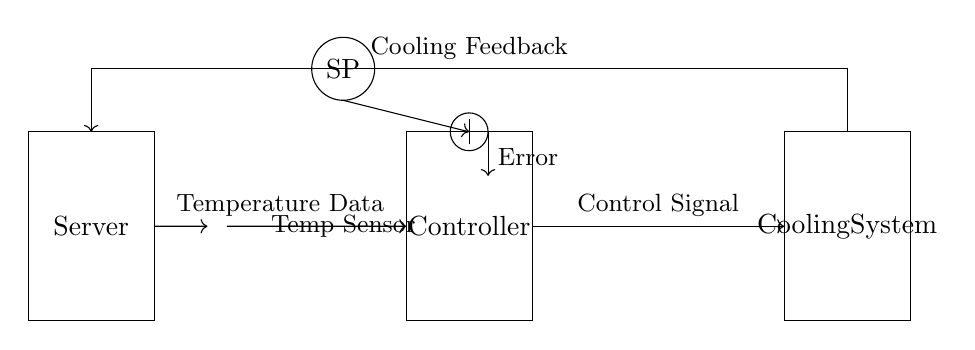What component measures temperature? The temperature sensor is depicted in the diagram, clearly labeled as "Temp Sensor," and it is represented by a thermistor symbol. This indicates that this component is responsible for measuring the temperature of the server.
Answer: Temp Sensor What does "SP" stand for in this circuit? "SP" is labeled in the diagram as the setpoint, which represents the desired temperature level that the system aims to maintain within the server. This indicates where the temperature feedback will be compared against.
Answer: Setpoint What type of feedback is represented in this circuit? The circuit includes a feedback loop that returns cooling feedback from the cooling system back to the setpoint, indicated as "Cooling Feedback." This implies that the system adjusts based on the cooling performance compared to the desired temperature.
Answer: Cooling Feedback Which component receives the temperature data? The temperature data is sent from the server to the temperature sensor, which is clearly indicated by the directed arrow showing the flow of data from the server to the sensor.
Answer: Temperature Sensor What is the role of the controller in this circuit? The controller, identified in the circuit, processes the temperature data received from the temperature sensor as well as the setpoint. It determines the necessary control signal to the cooling system to maintain the server's temperature.
Answer: Processing Temperature Data How does the error signal function in this feedback system? The error signal is derived from the comparison between the setpoint and the actual temperature data as processed by the controller. It indicates how much adjustment is required by the cooling system to reach the desired temperature, which is essential in feedback control mechanisms.
Answer: Indicates Temperature Adjustment 